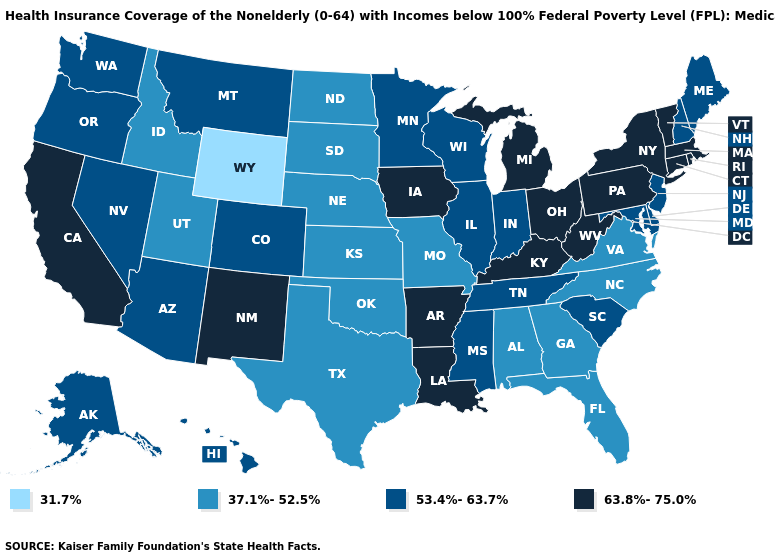Name the states that have a value in the range 37.1%-52.5%?
Short answer required. Alabama, Florida, Georgia, Idaho, Kansas, Missouri, Nebraska, North Carolina, North Dakota, Oklahoma, South Dakota, Texas, Utah, Virginia. What is the lowest value in states that border Maine?
Keep it brief. 53.4%-63.7%. Does the first symbol in the legend represent the smallest category?
Be succinct. Yes. Does the first symbol in the legend represent the smallest category?
Be succinct. Yes. What is the value of Maine?
Answer briefly. 53.4%-63.7%. What is the value of Mississippi?
Write a very short answer. 53.4%-63.7%. What is the highest value in the MidWest ?
Be succinct. 63.8%-75.0%. Does Louisiana have the highest value in the USA?
Concise answer only. Yes. What is the value of Michigan?
Keep it brief. 63.8%-75.0%. Name the states that have a value in the range 37.1%-52.5%?
Be succinct. Alabama, Florida, Georgia, Idaho, Kansas, Missouri, Nebraska, North Carolina, North Dakota, Oklahoma, South Dakota, Texas, Utah, Virginia. Is the legend a continuous bar?
Write a very short answer. No. Name the states that have a value in the range 37.1%-52.5%?
Be succinct. Alabama, Florida, Georgia, Idaho, Kansas, Missouri, Nebraska, North Carolina, North Dakota, Oklahoma, South Dakota, Texas, Utah, Virginia. Among the states that border Montana , which have the highest value?
Give a very brief answer. Idaho, North Dakota, South Dakota. Name the states that have a value in the range 37.1%-52.5%?
Concise answer only. Alabama, Florida, Georgia, Idaho, Kansas, Missouri, Nebraska, North Carolina, North Dakota, Oklahoma, South Dakota, Texas, Utah, Virginia. What is the value of Pennsylvania?
Short answer required. 63.8%-75.0%. 